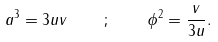<formula> <loc_0><loc_0><loc_500><loc_500>a ^ { 3 } = 3 u v \quad ; \quad \phi ^ { 2 } = \frac { v } { 3 u } .</formula> 